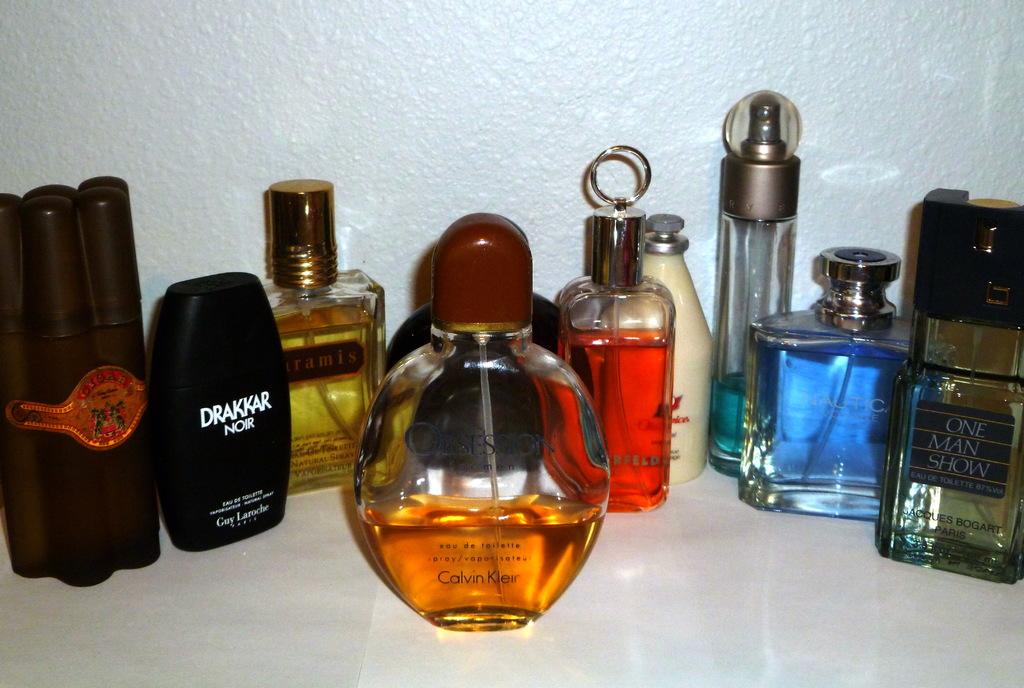What is the name of the cologne in the bottle on the far right?
Provide a succinct answer. One man show. 